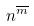<formula> <loc_0><loc_0><loc_500><loc_500>n ^ { \overline { m } }</formula> 